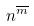<formula> <loc_0><loc_0><loc_500><loc_500>n ^ { \overline { m } }</formula> 